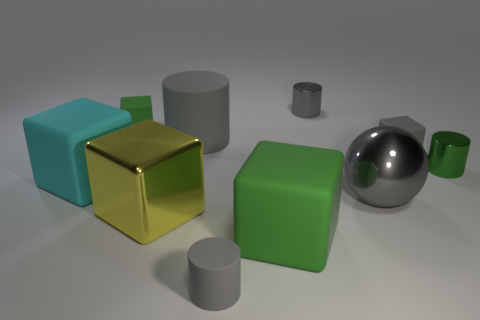Subtract all purple cubes. How many gray cylinders are left? 3 Subtract all gray cubes. How many cubes are left? 4 Subtract 1 cubes. How many cubes are left? 4 Subtract all gray blocks. How many blocks are left? 4 Subtract all blue blocks. Subtract all cyan cylinders. How many blocks are left? 5 Subtract all spheres. How many objects are left? 9 Add 1 large gray things. How many large gray things are left? 3 Add 2 green cylinders. How many green cylinders exist? 3 Subtract 1 gray spheres. How many objects are left? 9 Subtract all brown cubes. Subtract all big rubber things. How many objects are left? 7 